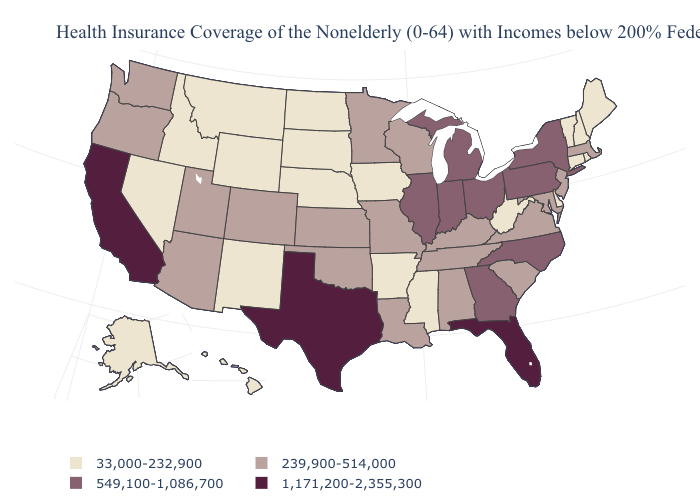What is the value of Wyoming?
Keep it brief. 33,000-232,900. What is the lowest value in the USA?
Answer briefly. 33,000-232,900. Does the map have missing data?
Keep it brief. No. Which states hav the highest value in the Northeast?
Be succinct. New York, Pennsylvania. Name the states that have a value in the range 33,000-232,900?
Concise answer only. Alaska, Arkansas, Connecticut, Delaware, Hawaii, Idaho, Iowa, Maine, Mississippi, Montana, Nebraska, Nevada, New Hampshire, New Mexico, North Dakota, Rhode Island, South Dakota, Vermont, West Virginia, Wyoming. Does Pennsylvania have a higher value than Georgia?
Quick response, please. No. Name the states that have a value in the range 239,900-514,000?
Quick response, please. Alabama, Arizona, Colorado, Kansas, Kentucky, Louisiana, Maryland, Massachusetts, Minnesota, Missouri, New Jersey, Oklahoma, Oregon, South Carolina, Tennessee, Utah, Virginia, Washington, Wisconsin. Among the states that border Indiana , does Illinois have the lowest value?
Concise answer only. No. Does Pennsylvania have the lowest value in the USA?
Be succinct. No. What is the value of Colorado?
Give a very brief answer. 239,900-514,000. Name the states that have a value in the range 549,100-1,086,700?
Be succinct. Georgia, Illinois, Indiana, Michigan, New York, North Carolina, Ohio, Pennsylvania. Does Tennessee have the lowest value in the South?
Keep it brief. No. Which states have the highest value in the USA?
Write a very short answer. California, Florida, Texas. What is the value of Indiana?
Be succinct. 549,100-1,086,700. Which states have the highest value in the USA?
Concise answer only. California, Florida, Texas. 